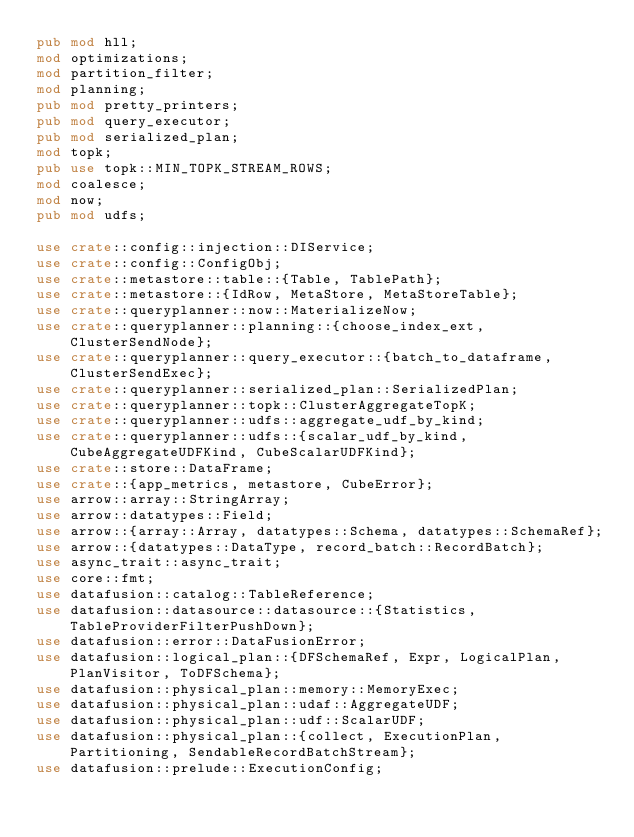Convert code to text. <code><loc_0><loc_0><loc_500><loc_500><_Rust_>pub mod hll;
mod optimizations;
mod partition_filter;
mod planning;
pub mod pretty_printers;
pub mod query_executor;
pub mod serialized_plan;
mod topk;
pub use topk::MIN_TOPK_STREAM_ROWS;
mod coalesce;
mod now;
pub mod udfs;

use crate::config::injection::DIService;
use crate::config::ConfigObj;
use crate::metastore::table::{Table, TablePath};
use crate::metastore::{IdRow, MetaStore, MetaStoreTable};
use crate::queryplanner::now::MaterializeNow;
use crate::queryplanner::planning::{choose_index_ext, ClusterSendNode};
use crate::queryplanner::query_executor::{batch_to_dataframe, ClusterSendExec};
use crate::queryplanner::serialized_plan::SerializedPlan;
use crate::queryplanner::topk::ClusterAggregateTopK;
use crate::queryplanner::udfs::aggregate_udf_by_kind;
use crate::queryplanner::udfs::{scalar_udf_by_kind, CubeAggregateUDFKind, CubeScalarUDFKind};
use crate::store::DataFrame;
use crate::{app_metrics, metastore, CubeError};
use arrow::array::StringArray;
use arrow::datatypes::Field;
use arrow::{array::Array, datatypes::Schema, datatypes::SchemaRef};
use arrow::{datatypes::DataType, record_batch::RecordBatch};
use async_trait::async_trait;
use core::fmt;
use datafusion::catalog::TableReference;
use datafusion::datasource::datasource::{Statistics, TableProviderFilterPushDown};
use datafusion::error::DataFusionError;
use datafusion::logical_plan::{DFSchemaRef, Expr, LogicalPlan, PlanVisitor, ToDFSchema};
use datafusion::physical_plan::memory::MemoryExec;
use datafusion::physical_plan::udaf::AggregateUDF;
use datafusion::physical_plan::udf::ScalarUDF;
use datafusion::physical_plan::{collect, ExecutionPlan, Partitioning, SendableRecordBatchStream};
use datafusion::prelude::ExecutionConfig;</code> 